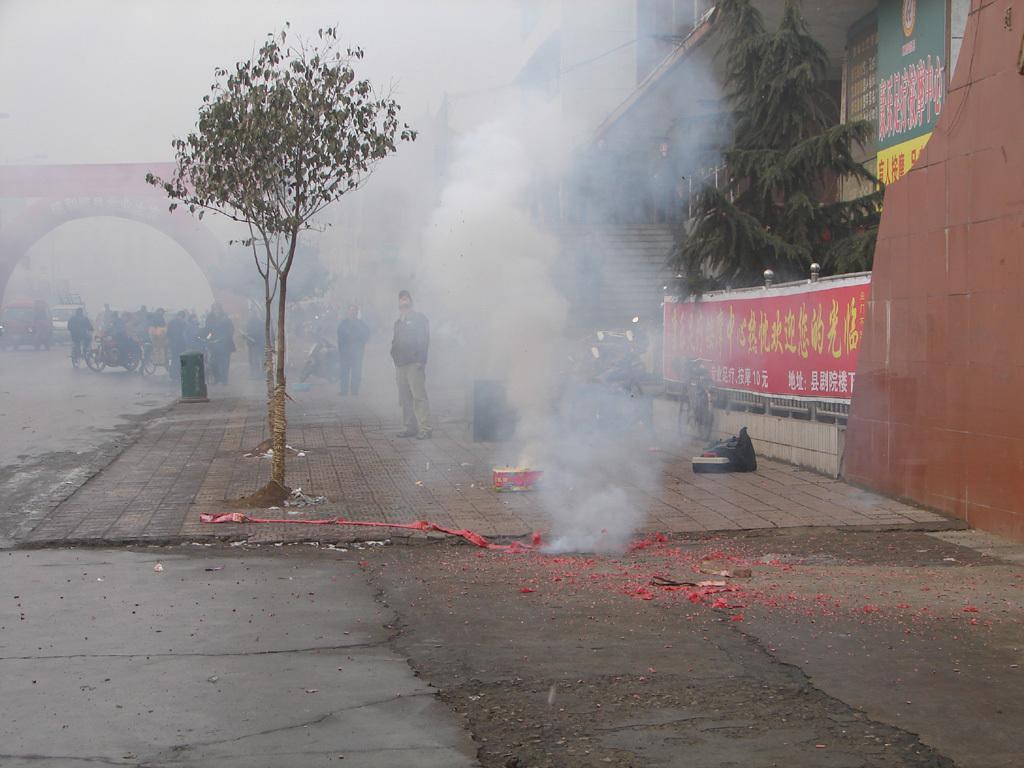Can you describe this image briefly? In this picture we can see road, smoke, wall and trees. There are people and we can see dustbin, building, vehicle on the road, boards and objects. In the background of the image it looks like an arch and we can see the sky. 